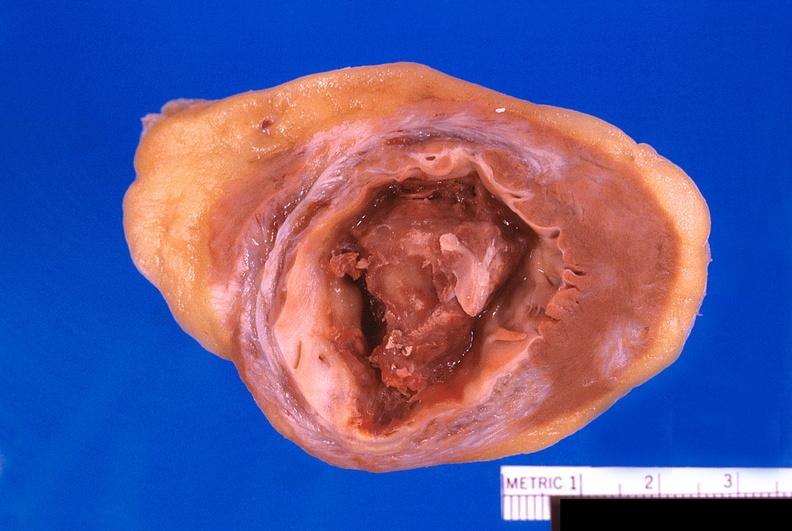what does this image show?
Answer the question using a single word or phrase. Heart 